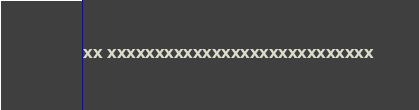Convert code to text. <code><loc_0><loc_0><loc_500><loc_500><_Python_>XX XXXXXXXXXXXXXXXXXXXXXXXXXXXX
</code> 